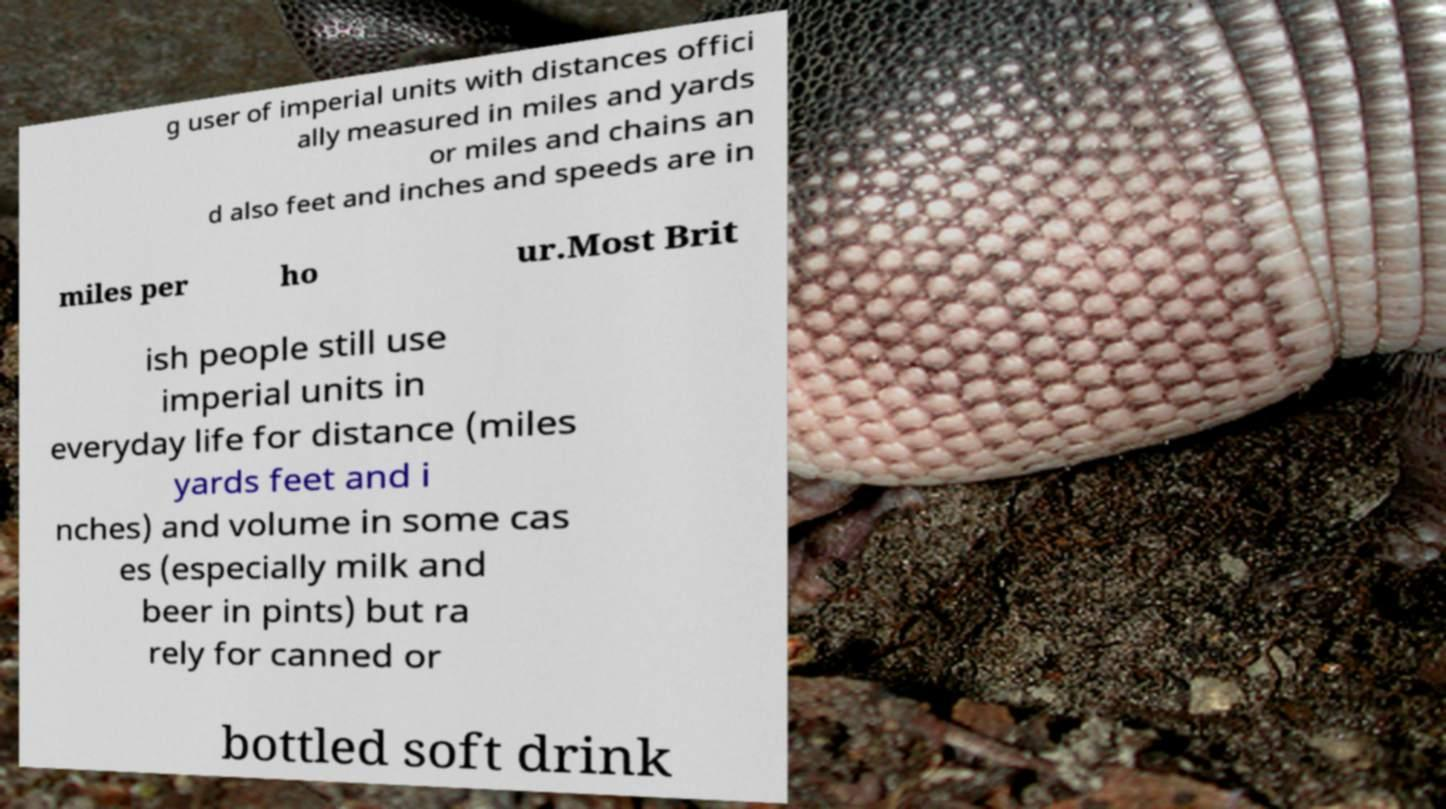What messages or text are displayed in this image? I need them in a readable, typed format. g user of imperial units with distances offici ally measured in miles and yards or miles and chains an d also feet and inches and speeds are in miles per ho ur.Most Brit ish people still use imperial units in everyday life for distance (miles yards feet and i nches) and volume in some cas es (especially milk and beer in pints) but ra rely for canned or bottled soft drink 